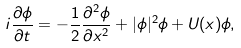<formula> <loc_0><loc_0><loc_500><loc_500>i \frac { \partial \phi } { \partial t } = - \frac { 1 } { 2 } \frac { \partial ^ { 2 } \phi } { \partial x ^ { 2 } } + | \phi | ^ { 2 } \phi + U ( x ) \phi ,</formula> 